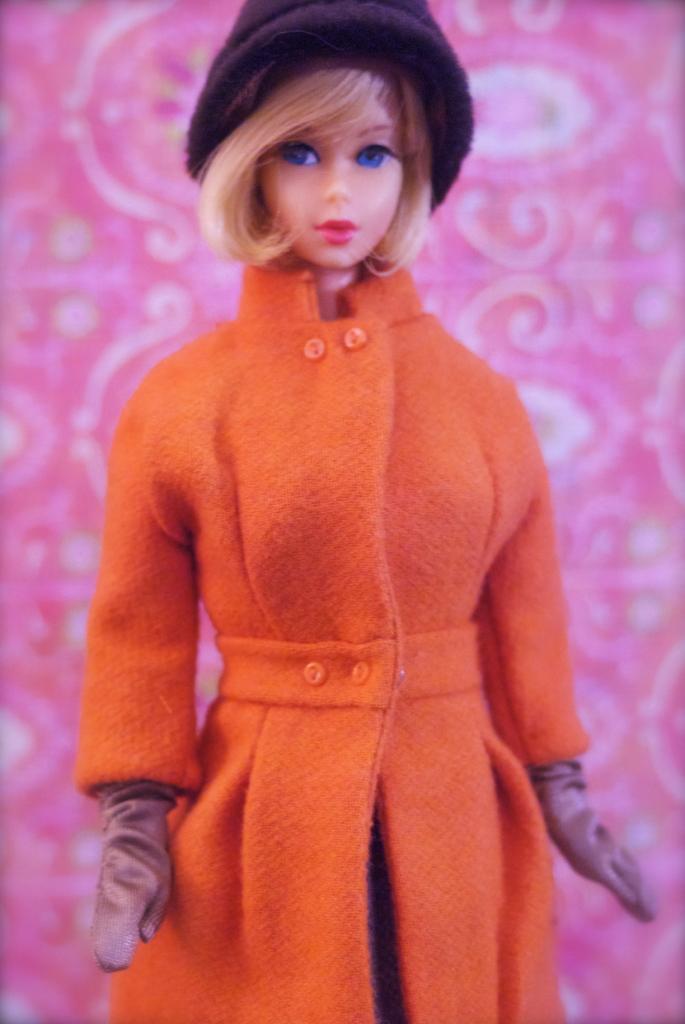Can you describe this image briefly? In this picture we can observe a doll. There is an orange color dress and gloves to the hands of the doll. We can observe black color cap on the head. The background is in pink color and we can observe a design on this pink color background. 